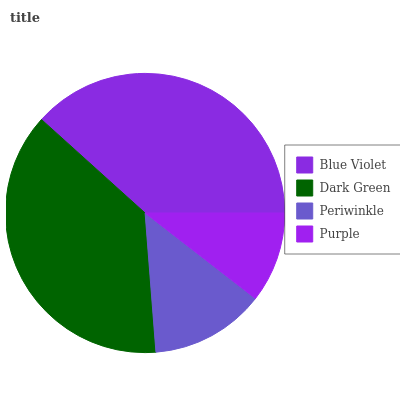Is Purple the minimum?
Answer yes or no. Yes. Is Blue Violet the maximum?
Answer yes or no. Yes. Is Dark Green the minimum?
Answer yes or no. No. Is Dark Green the maximum?
Answer yes or no. No. Is Blue Violet greater than Dark Green?
Answer yes or no. Yes. Is Dark Green less than Blue Violet?
Answer yes or no. Yes. Is Dark Green greater than Blue Violet?
Answer yes or no. No. Is Blue Violet less than Dark Green?
Answer yes or no. No. Is Dark Green the high median?
Answer yes or no. Yes. Is Periwinkle the low median?
Answer yes or no. Yes. Is Purple the high median?
Answer yes or no. No. Is Purple the low median?
Answer yes or no. No. 